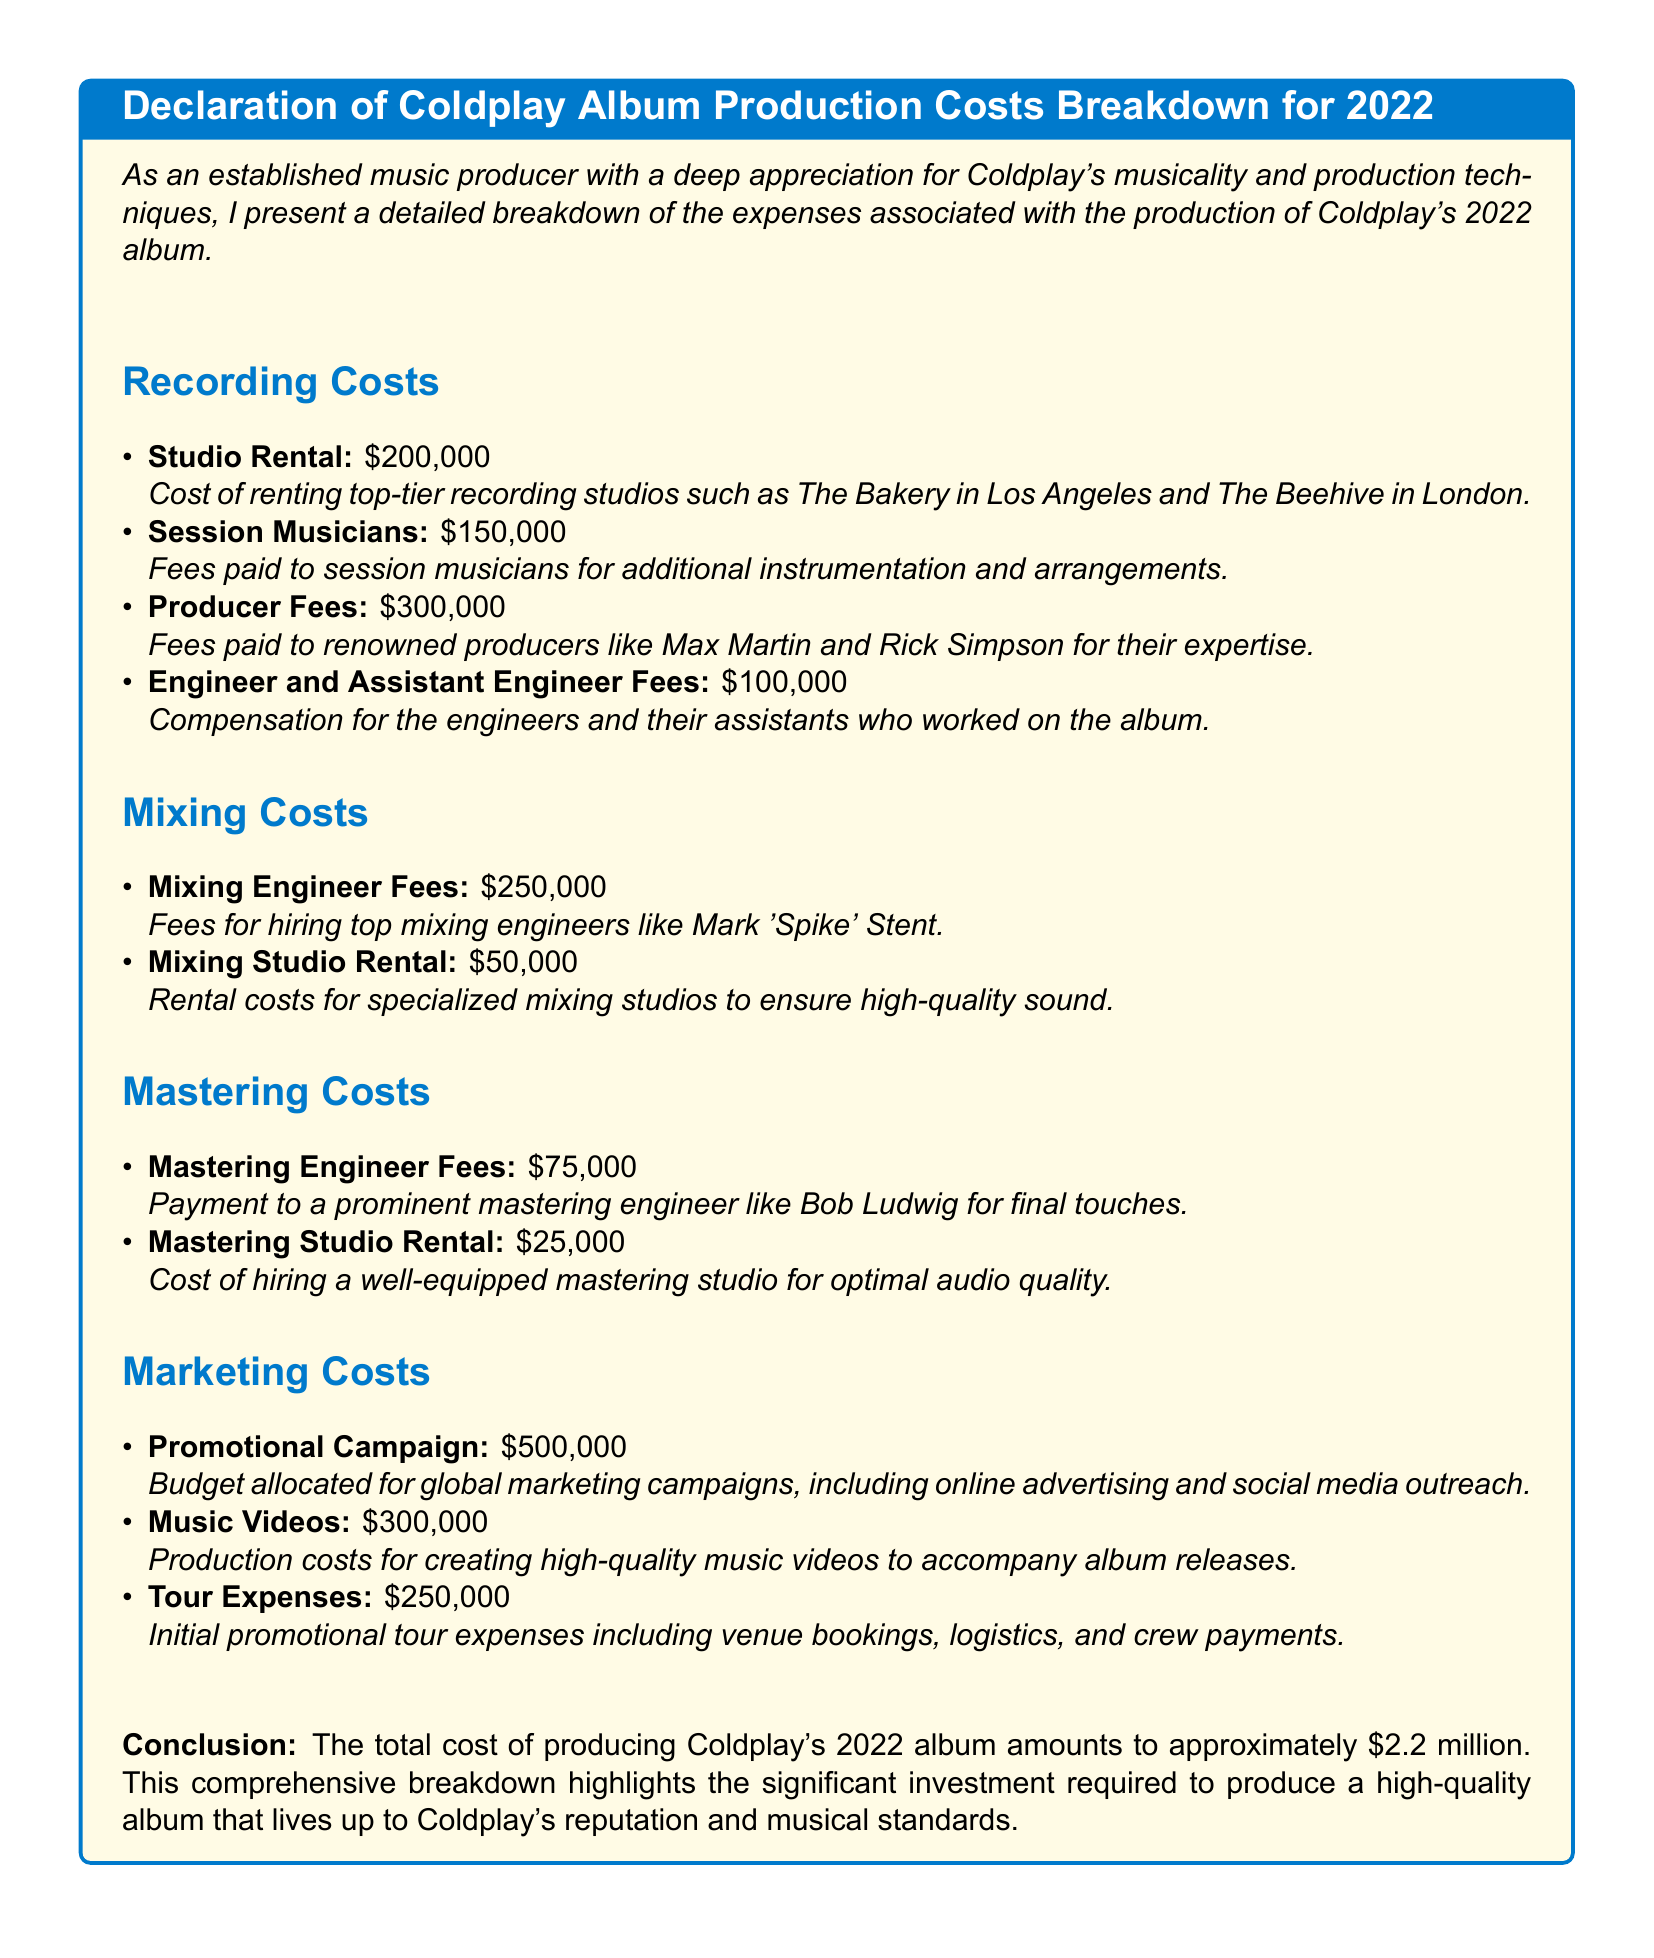What is the total production cost? The total production cost is listed in the conclusion of the document as the sum of all expenses, which amounts to approximately $2.2 million.
Answer: $2.2 million What was the studio rental cost? The document provides a specific expense amount for studio rental under recording costs, which is $200,000.
Answer: $200,000 Who were the renowned producers? The document mentions specific renowned producers associated with producer fees, including Max Martin and Rick Simpson.
Answer: Max Martin and Rick Simpson How much was spent on promotional campaigns? The expense for promotional campaigns is detailed under marketing costs, stated as $500,000.
Answer: $500,000 What is the cost for hiring a mastering studio? The document specifies the cost for mastering studio rental under mastering costs as $25,000.
Answer: $25,000 What are the initial tour expenses? The initial promotional tour expenses are outlined in the marketing section as $250,000.
Answer: $250,000 How many categories of costs are identified in the document? The document identifies four main categories of costs related to album production: recording, mixing, mastering, and marketing.
Answer: Four What are the fees for mixing engineers? The document specifies the fees for mixing engineers as $250,000 within the mixing costs section.
Answer: $250,000 Who is the prominent mastering engineer mentioned? The document refers to a prominent mastering engineer, specifically Bob Ludwig, in the mastering costs section.
Answer: Bob Ludwig 